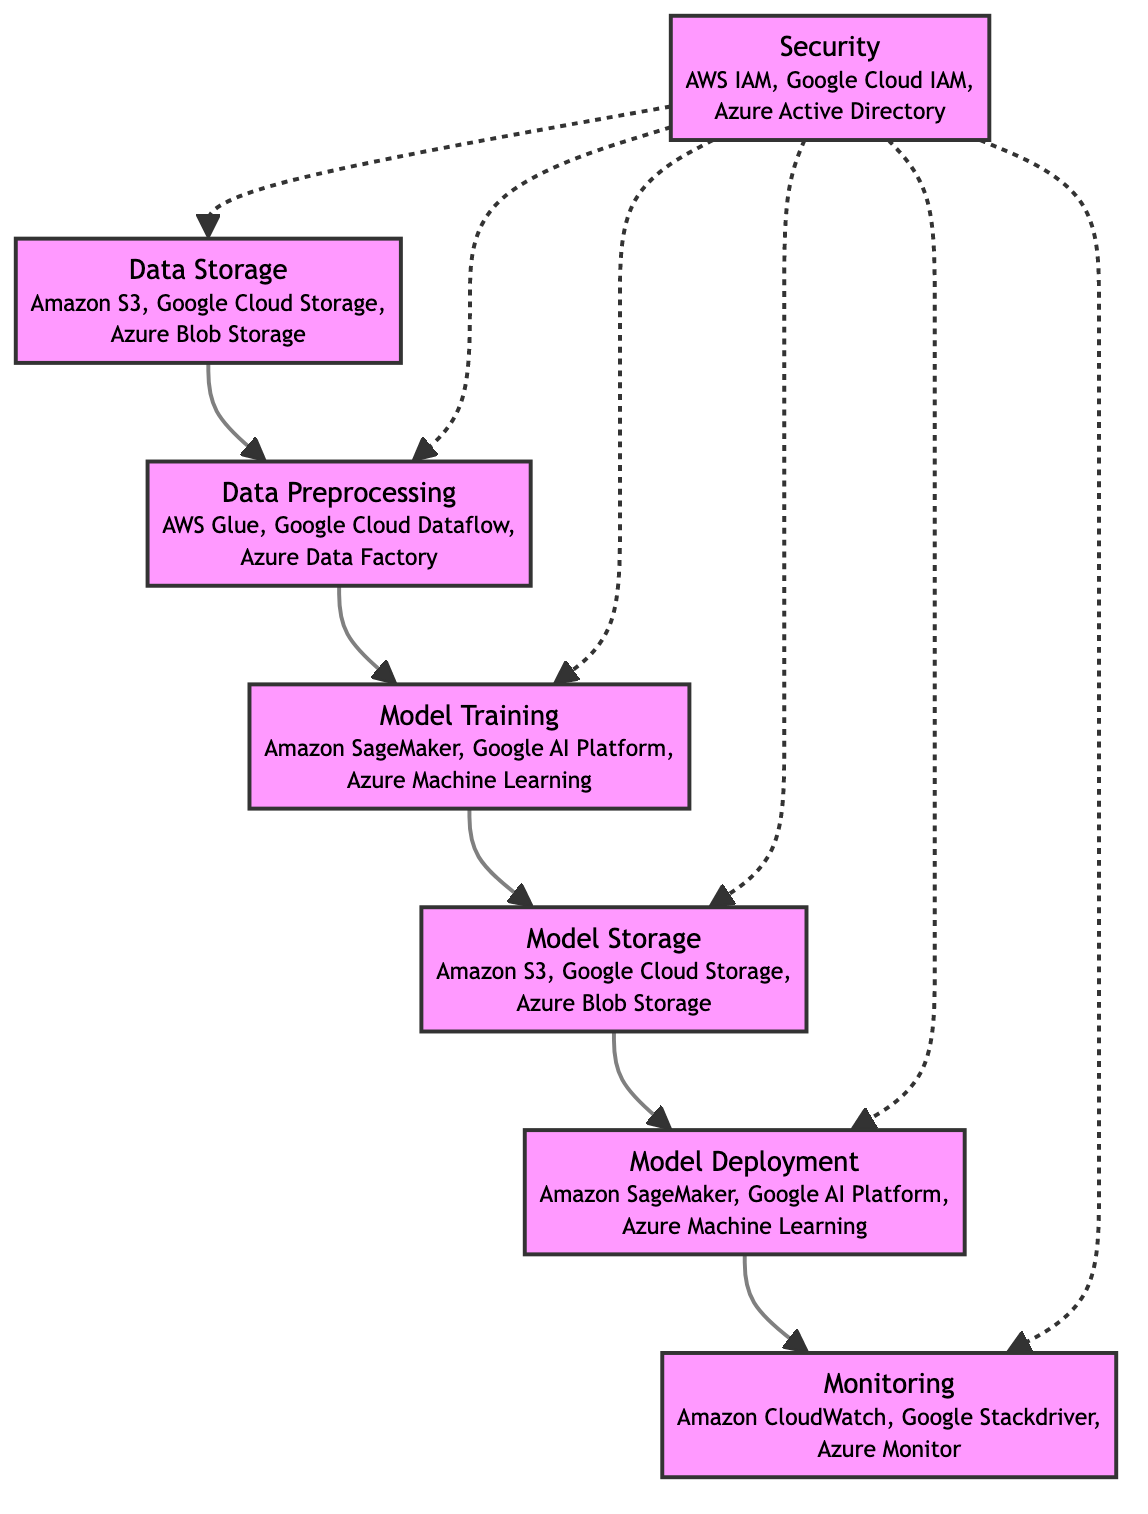What is the first block in the diagram? The first block in the flowchart is "Data Storage". It's the initial step before all other processes occur, shown at the top of the diagram.
Answer: Data Storage How many services are listed for "Model Training"? The block "Model Training" lists three services: Amazon SageMaker, Google AI Platform, and Azure Machine Learning. The information about these services is presented under the block, leading to a count of three.
Answer: 3 Which block directly follows "Data Preprocessing"? The block that directly follows "Data Preprocessing" is "Model Training". This can be observed by tracing the arrow connection from "Data Preprocessing" to "Model Training".
Answer: Model Training What role does "Security" play in the diagram? "Security" ensures the integrity and protection of all other components. It is depicted with dashed lines that connect to multiple blocks, indicating it influences the entire data flow without being directly part of the main process flow.
Answer: Ensures security and integrity How many blocks are interconnected by the "Security" block? The "Security" block connects to five other blocks in the diagram: "Data Storage", "Data Preprocessing", "Model Training", "Model Storage", and "Model Deployment", with all connections shown clearly by the dashed lines.
Answer: 5 What is shared between "Data Storage" and "Model Storage"? Both "Data Storage" and "Model Storage" share the same services: Amazon S3, Google Cloud Storage, and Azure Blob Storage. This shows how data used for training is stored similarly as the final trained model.
Answer: Amazon S3, Google Cloud Storage, Azure Blob Storage What is the final block in the flow of the diagram? The final block in the flow is "Monitoring". This can be seen as the last step of the process, following "Model Deployment" and indicating the performance tracking of the deployed model.
Answer: Monitoring Which service under "Monitoring" is provided by Amazon? The service listed under "Monitoring" provided by Amazon is "Amazon CloudWatch". This service is one of the options mentioned for monitoring the performance of the deployed model.
Answer: Amazon CloudWatch 